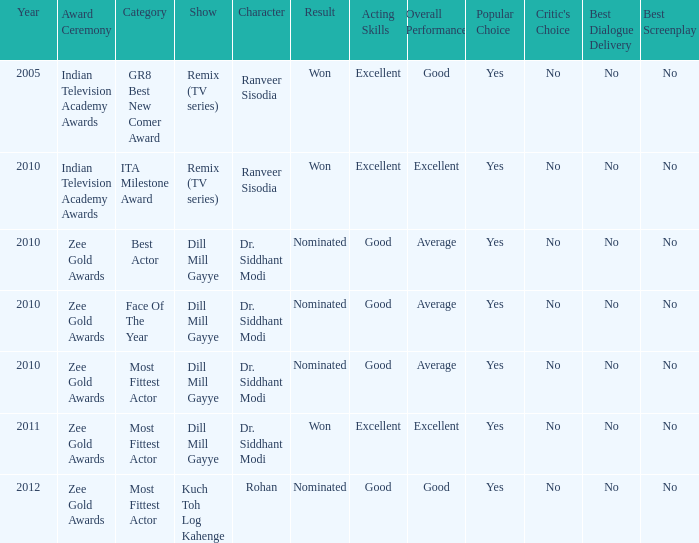Which character was nominated in the 2010 Indian Television Academy Awards? Ranveer Sisodia. 